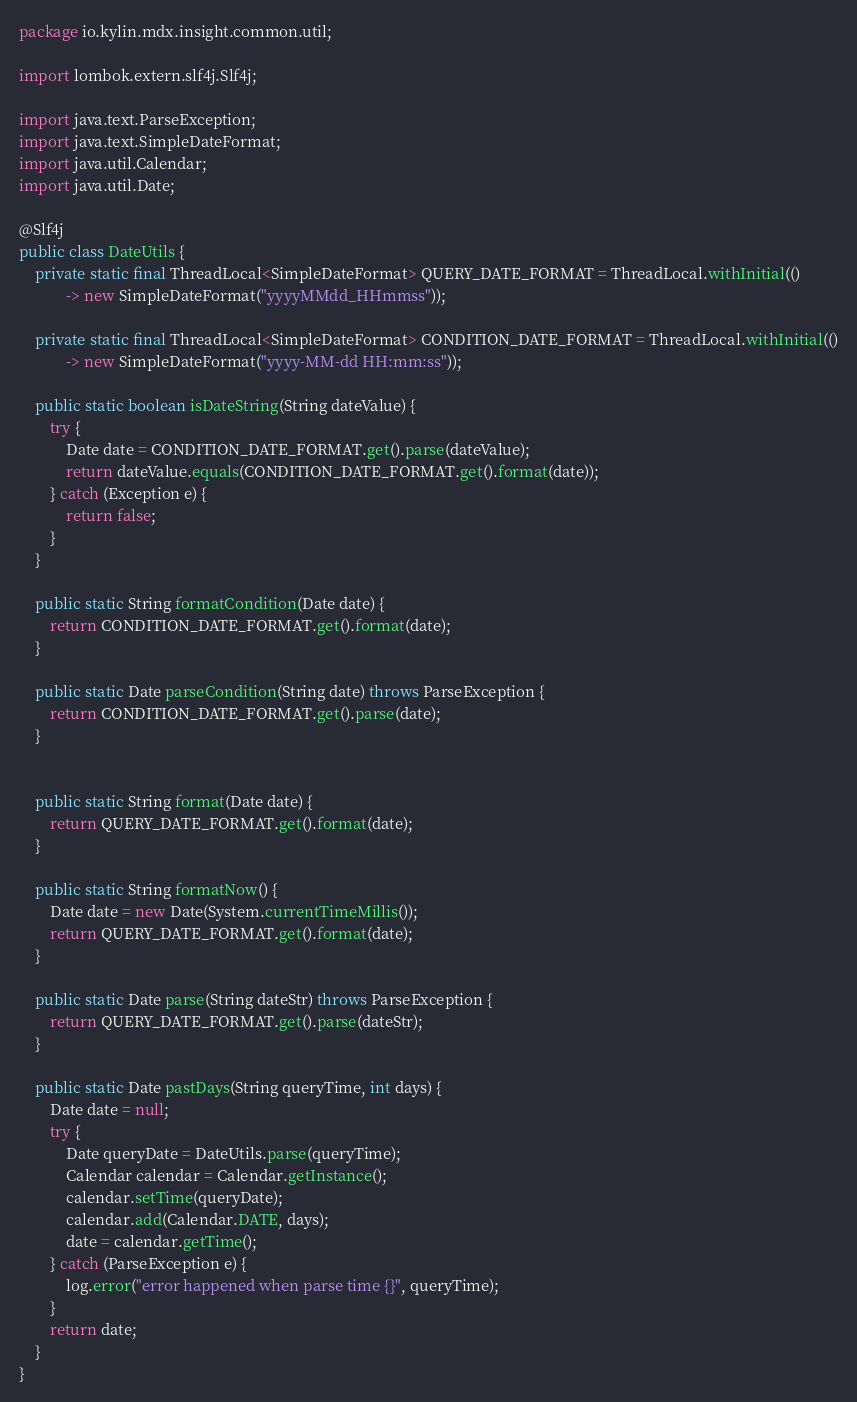Convert code to text. <code><loc_0><loc_0><loc_500><loc_500><_Java_>package io.kylin.mdx.insight.common.util;

import lombok.extern.slf4j.Slf4j;

import java.text.ParseException;
import java.text.SimpleDateFormat;
import java.util.Calendar;
import java.util.Date;

@Slf4j
public class DateUtils {
    private static final ThreadLocal<SimpleDateFormat> QUERY_DATE_FORMAT = ThreadLocal.withInitial(()
            -> new SimpleDateFormat("yyyyMMdd_HHmmss"));

    private static final ThreadLocal<SimpleDateFormat> CONDITION_DATE_FORMAT = ThreadLocal.withInitial(()
            -> new SimpleDateFormat("yyyy-MM-dd HH:mm:ss"));

    public static boolean isDateString(String dateValue) {
        try {
            Date date = CONDITION_DATE_FORMAT.get().parse(dateValue);
            return dateValue.equals(CONDITION_DATE_FORMAT.get().format(date));
        } catch (Exception e) {
            return false;
        }
    }

    public static String formatCondition(Date date) {
        return CONDITION_DATE_FORMAT.get().format(date);
    }

    public static Date parseCondition(String date) throws ParseException {
        return CONDITION_DATE_FORMAT.get().parse(date);
    }


    public static String format(Date date) {
        return QUERY_DATE_FORMAT.get().format(date);
    }

    public static String formatNow() {
        Date date = new Date(System.currentTimeMillis());
        return QUERY_DATE_FORMAT.get().format(date);
    }

    public static Date parse(String dateStr) throws ParseException {
        return QUERY_DATE_FORMAT.get().parse(dateStr);
    }

    public static Date pastDays(String queryTime, int days) {
        Date date = null;
        try {
            Date queryDate = DateUtils.parse(queryTime);
            Calendar calendar = Calendar.getInstance();
            calendar.setTime(queryDate);
            calendar.add(Calendar.DATE, days);
            date = calendar.getTime();
        } catch (ParseException e) {
            log.error("error happened when parse time {}", queryTime);
        }
        return date;
    }
}
</code> 